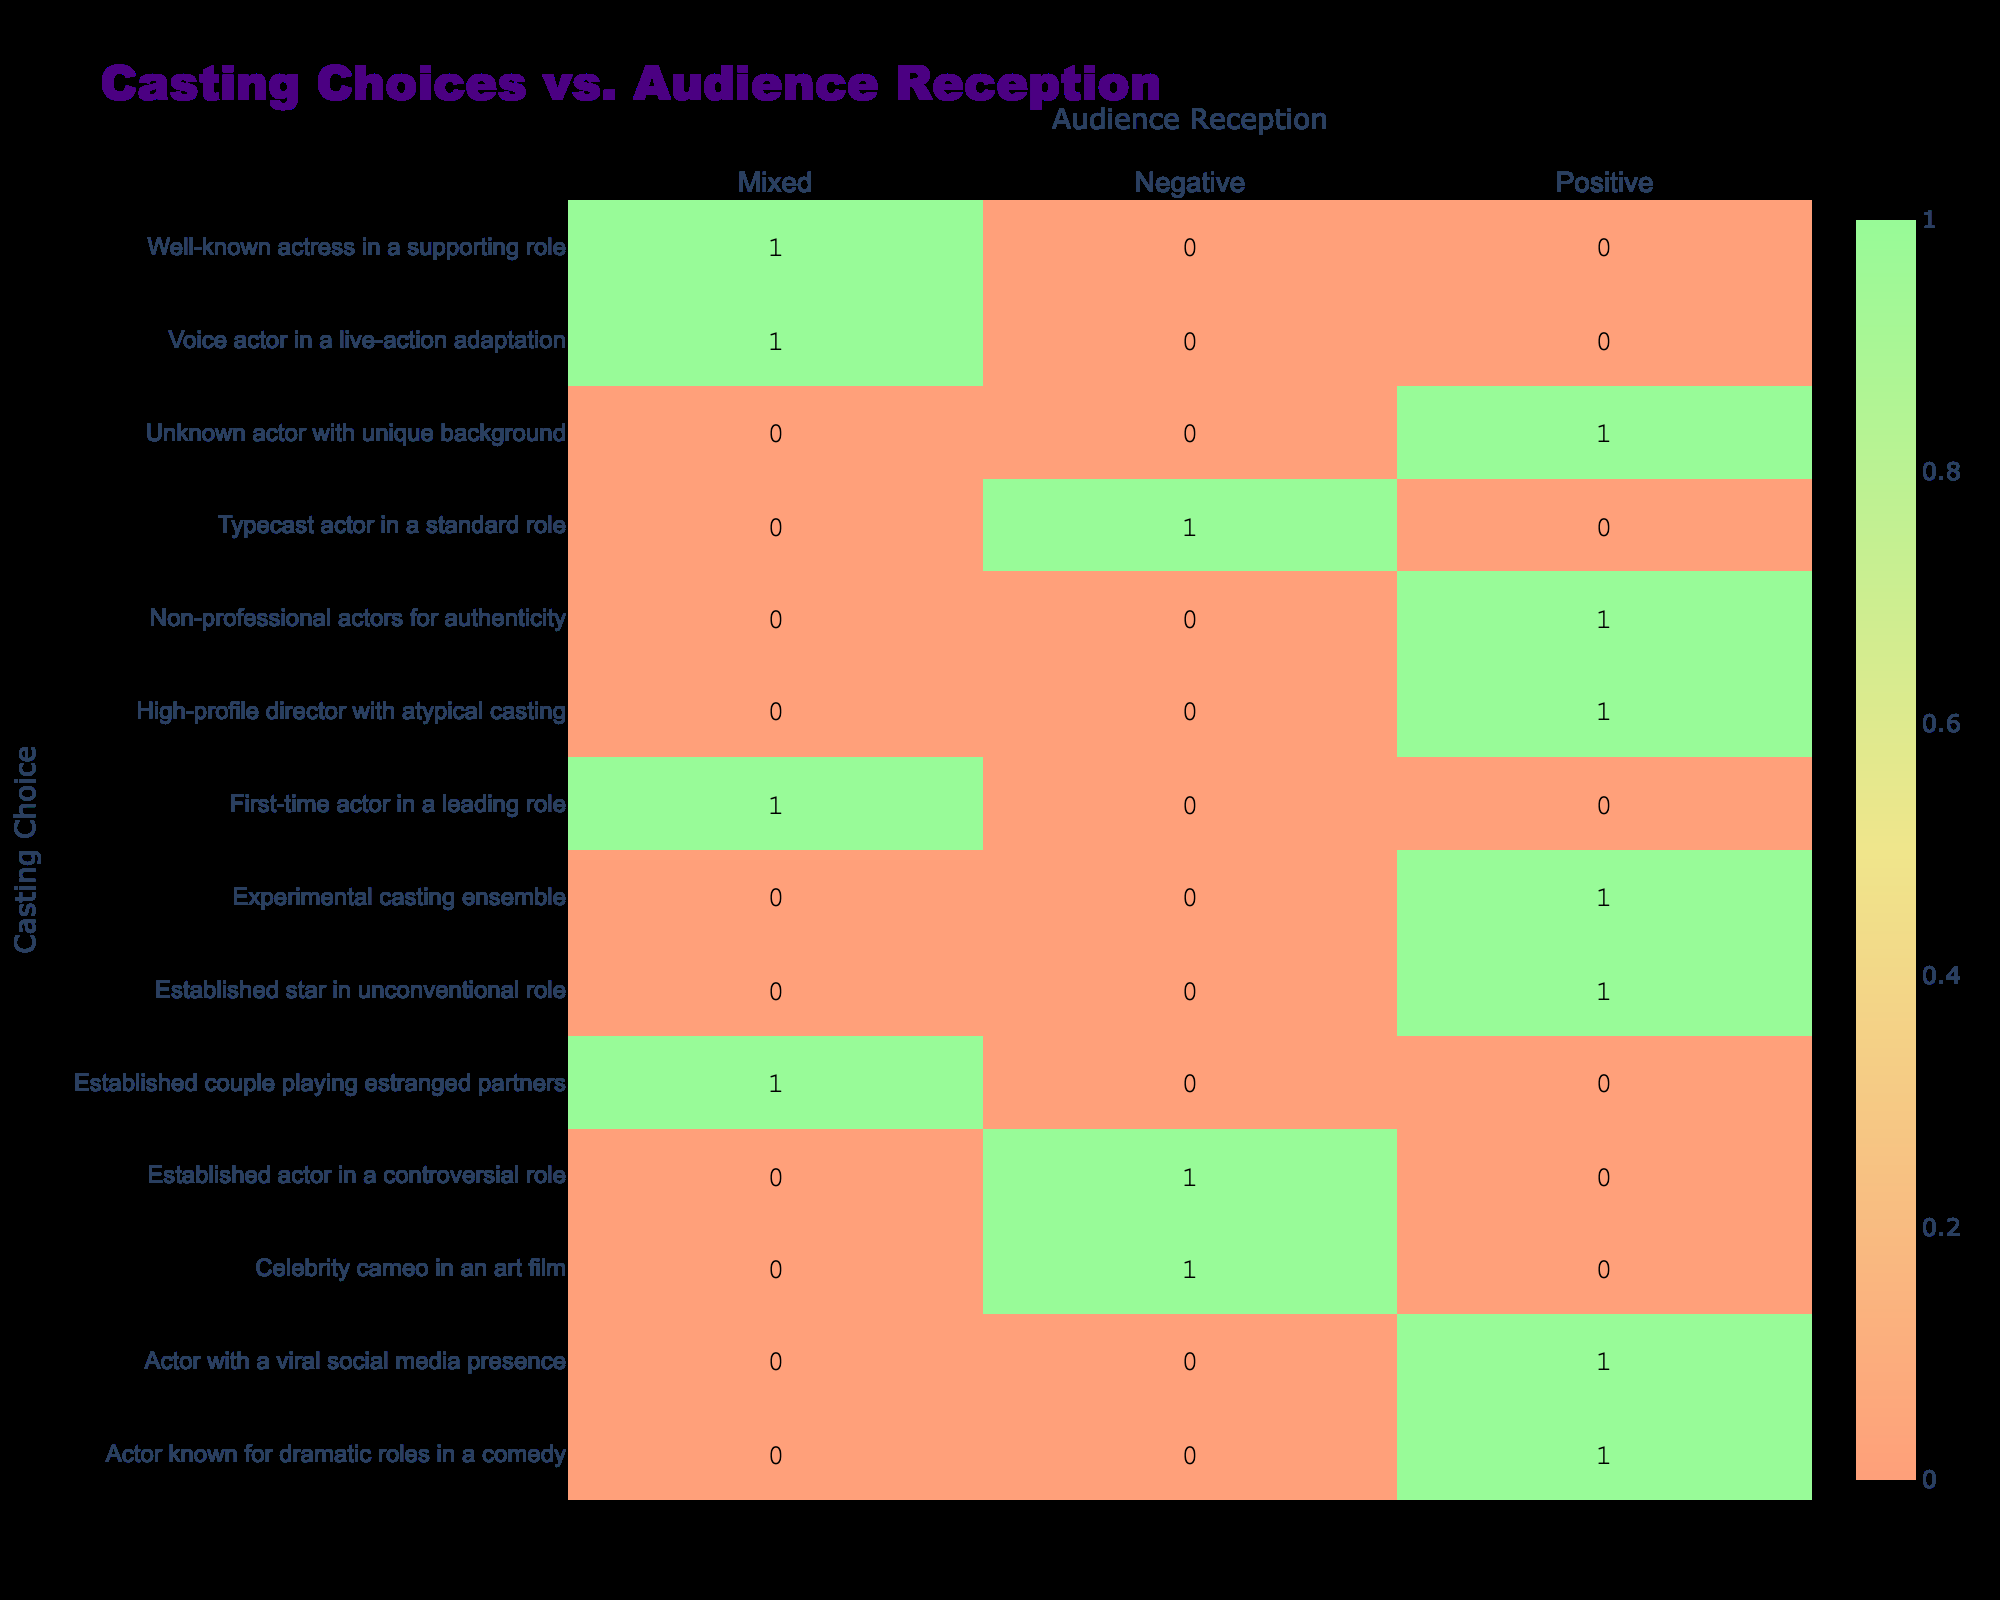What is the audience reception for "Established star in unconventional role"? The table shows that the audience reception for "Established star in unconventional role" is classified as Positive.
Answer: Positive How many casting choices received a Mixed audience reception? According to the table, three casting choices received a Mixed audience reception: "First-time actor in a leading role," "Well-known actress in a supporting role," and "Established couple playing estranged partners." Therefore, the total is 3.
Answer: 3 Is "Actor known for dramatic roles in a comedy" associated with a Positive audience reception? Yes, the table indicates that "Actor known for dramatic roles in a comedy" is associated with a Positive audience reception.
Answer: Yes What is the total count of Negative audience receptions among the casting choices? The table shows that there are three casting choices associated with Negative audience receptions: "Established actor in a controversial role," "Typecast actor in a standard role," and "Celebrity cameo in an art film," thus the total count is 3.
Answer: 3 Which casting choice has the highest Positive audience reception, and what is the count? The casting choice "Experimental casting ensemble" has the highest Positive audience reception, and from the table, it shows that this choice is counted as 1.
Answer: 1 What is the difference in audience reception counts between Positive and Negative for the "Unknown actor with unique background"? The audience reception for the "Unknown actor with unique background" is Positive (count of 1), and there are no counts for Negative receptions for this specific casting choice. Thus, the difference is 1 (Positive) - 0 (Negative) = 1.
Answer: 1 How many casting choices are associated with an audience reception of Mixed, and what percentage does this represent out of the total casting choices? There are 3 casting choices associated with a Mixed reception out of a total of 12 casting choices. To find the percentage, we calculate (3/12) * 100 = 25%.
Answer: 25% What is the audience reception trend for casting choices involving established actors? The table shows that established actors received both Positive ("Established star in unconventional role") and Negative ("Established actor in a controversial role" and "Typecast actor in a standard role") receptions. Thus, the trend is mixed for established actors.
Answer: Mixed What is the overall balance of Positive to Negative audience receptions based on the table? Total Positive receptions are 7 (from the corresponding casting choices), and total Negative receptions are 3. Therefore, the overall balance favors Positive by a count of 4, indicating greater audience favor for Positive outcomes.
Answer: 4 